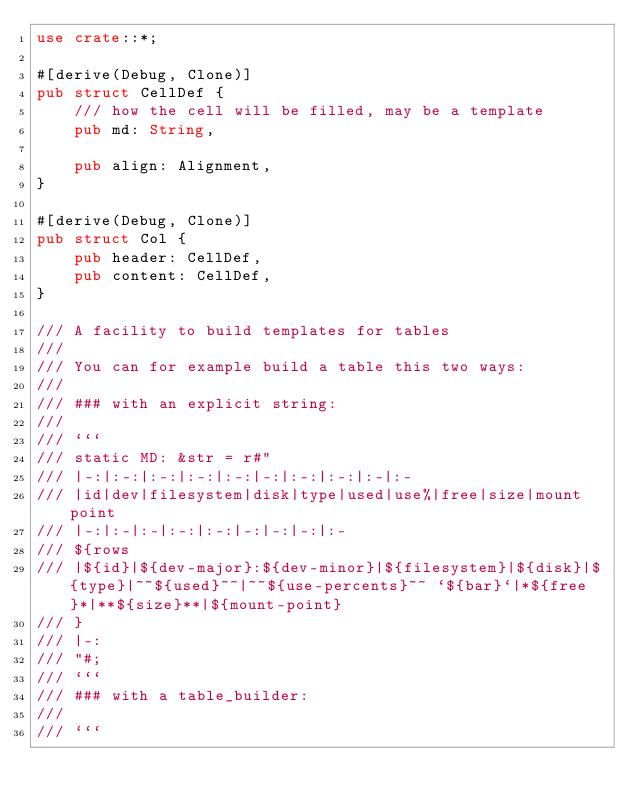Convert code to text. <code><loc_0><loc_0><loc_500><loc_500><_Rust_>use crate::*;

#[derive(Debug, Clone)]
pub struct CellDef {
    /// how the cell will be filled, may be a template
    pub md: String,

    pub align: Alignment,
}

#[derive(Debug, Clone)]
pub struct Col {
    pub header: CellDef,
    pub content: CellDef,
}

/// A facility to build templates for tables
///
/// You can for example build a table this two ways:
///
/// ### with an explicit string:
///
/// ```
/// static MD: &str = r#"
/// |-:|:-:|:-:|:-:|:-:|-:|:-:|:-:|:-|:-
/// |id|dev|filesystem|disk|type|used|use%|free|size|mount point
/// |-:|:-|:-|:-:|:-:|-:|-:|-:|:-
/// ${rows
/// |${id}|${dev-major}:${dev-minor}|${filesystem}|${disk}|${type}|~~${used}~~|~~${use-percents}~~ `${bar}`|*${free}*|**${size}**|${mount-point}
/// }
/// |-:
/// "#;
/// ```
/// ### with a table_builder:
///
/// ```</code> 